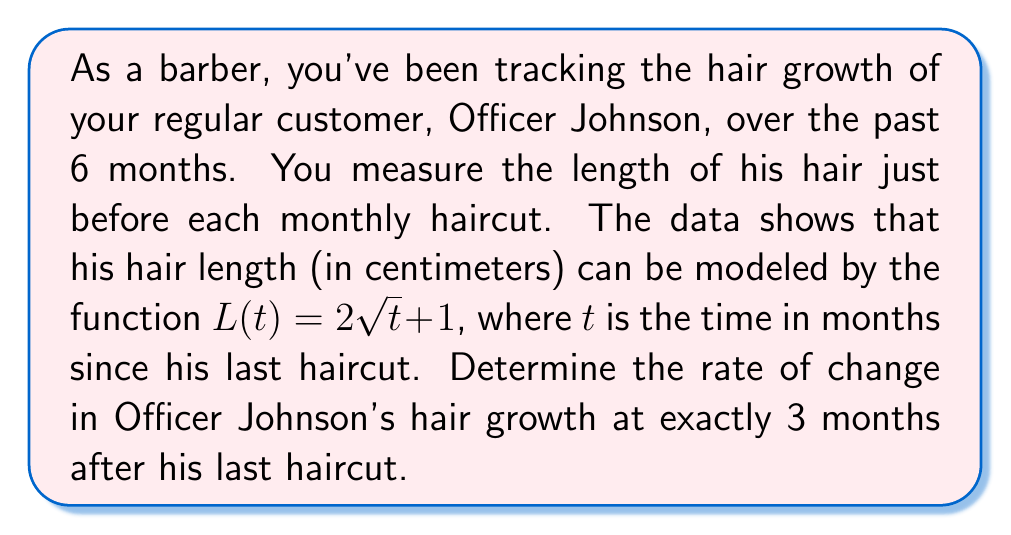Can you answer this question? To find the rate of change in hair growth at a specific point in time, we need to calculate the derivative of the given function and evaluate it at the specified time.

1) The given function is $L(t) = 2\sqrt{t} + 1$

2) To find the derivative, we use the power rule and the chain rule:
   $$\frac{d}{dt}(2\sqrt{t}) = 2 \cdot \frac{1}{2}t^{-1/2} = t^{-1/2} = \frac{1}{\sqrt{t}}$$
   The constant term 1 disappears when we take the derivative.

3) So, the derivative (rate of change) function is:
   $$L'(t) = \frac{1}{\sqrt{t}}$$

4) We want to find the rate of change at t = 3 months, so we substitute this value:
   $$L'(3) = \frac{1}{\sqrt{3}}$$

5) Simplify:
   $$L'(3) = \frac{1}{\sqrt{3}} = \frac{\sqrt{3}}{3} \approx 0.577$$

This means that at exactly 3 months after his last haircut, Officer Johnson's hair is growing at a rate of approximately 0.577 cm per month.
Answer: The rate of change in Officer Johnson's hair growth at exactly 3 months after his last haircut is $\frac{\sqrt{3}}{3}$ cm per month, or approximately 0.577 cm per month. 